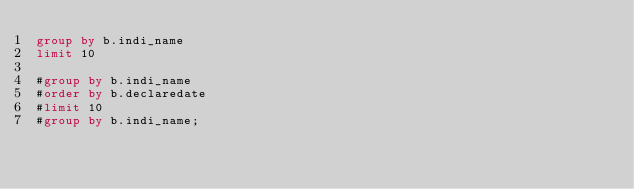<code> <loc_0><loc_0><loc_500><loc_500><_SQL_>group by b.indi_name
limit 10

#group by b.indi_name
#order by b.declaredate
#limit 10
#group by b.indi_name;</code> 